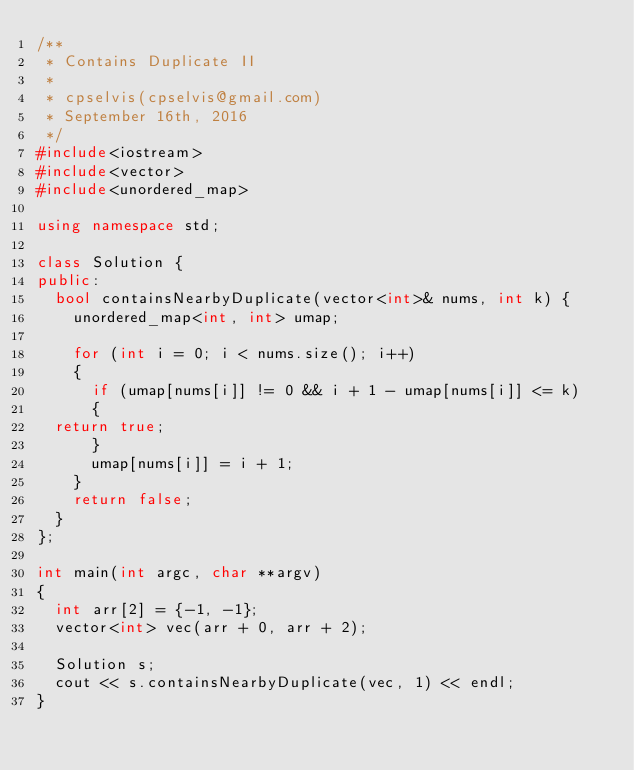Convert code to text. <code><loc_0><loc_0><loc_500><loc_500><_C++_>/** 
 * Contains Duplicate II
 *
 * cpselvis(cpselvis@gmail.com)
 * September 16th, 2016
 */
#include<iostream>
#include<vector>
#include<unordered_map>

using namespace std;

class Solution {
public:
  bool containsNearbyDuplicate(vector<int>& nums, int k) {
    unordered_map<int, int> umap;

    for (int i = 0; i < nums.size(); i++)
    {
      if (umap[nums[i]] != 0 && i + 1 - umap[nums[i]] <= k)
      {
	return true;
      }
      umap[nums[i]] = i + 1;
    }
    return false;
  }
};

int main(int argc, char **argv)
{
  int arr[2] = {-1, -1};
  vector<int> vec(arr + 0, arr + 2);

  Solution s;
  cout << s.containsNearbyDuplicate(vec, 1) << endl;
}
</code> 